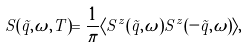Convert formula to latex. <formula><loc_0><loc_0><loc_500><loc_500>S ( { \vec { q } } , \omega , T ) = \frac { 1 } { \pi } \langle S ^ { z } ( { \vec { q } } , \omega ) S ^ { z } ( - { \vec { q } } , \omega ) \rangle ,</formula> 